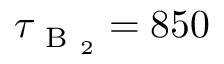Convert formula to latex. <formula><loc_0><loc_0><loc_500><loc_500>\tau _ { B _ { 2 } } = 8 5 0</formula> 